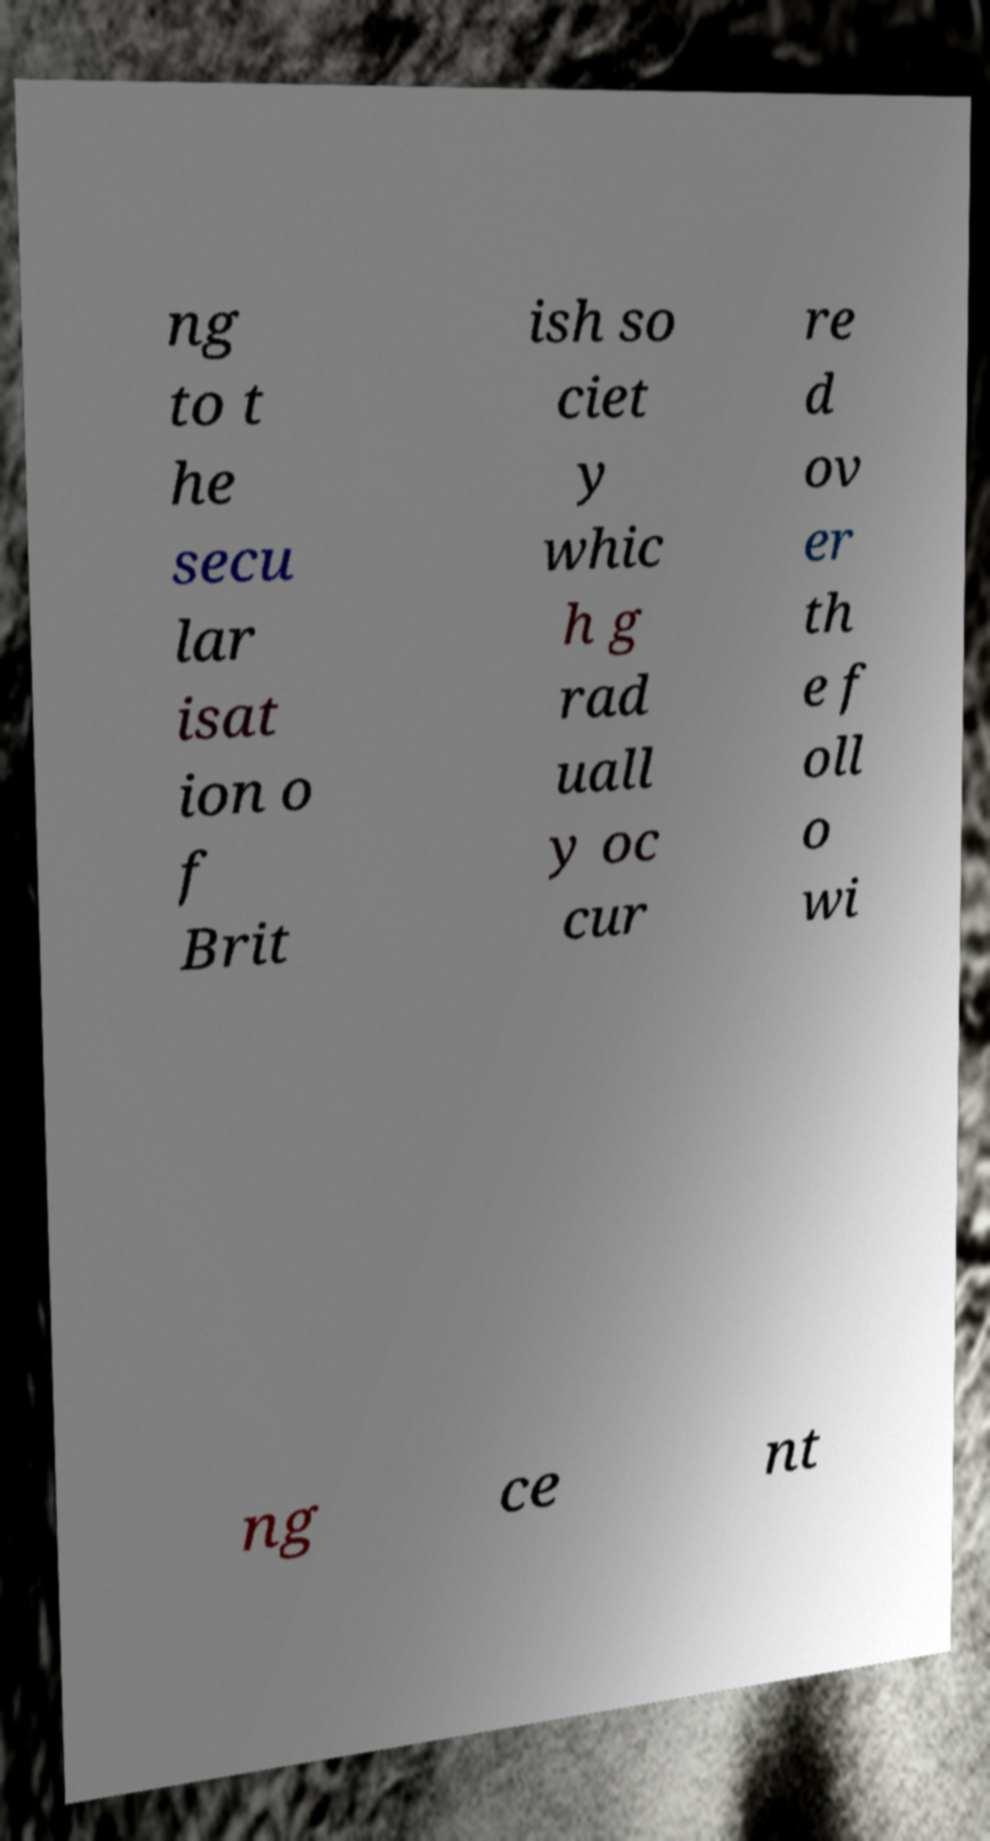Could you assist in decoding the text presented in this image and type it out clearly? ng to t he secu lar isat ion o f Brit ish so ciet y whic h g rad uall y oc cur re d ov er th e f oll o wi ng ce nt 